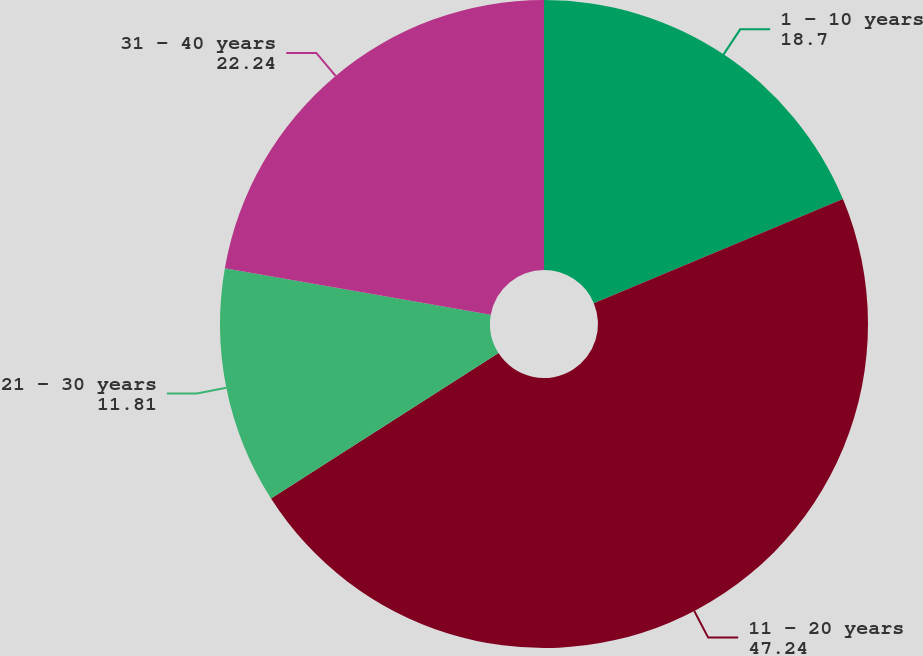Convert chart to OTSL. <chart><loc_0><loc_0><loc_500><loc_500><pie_chart><fcel>1 - 10 years<fcel>11 - 20 years<fcel>21 - 30 years<fcel>31 - 40 years<nl><fcel>18.7%<fcel>47.24%<fcel>11.81%<fcel>22.24%<nl></chart> 